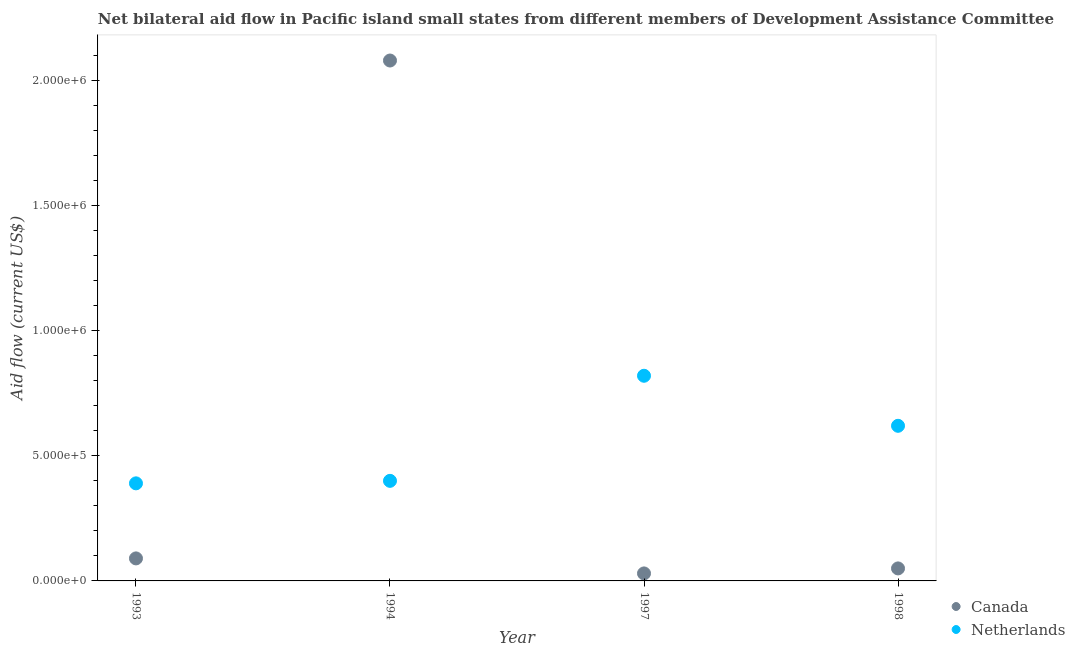How many different coloured dotlines are there?
Offer a very short reply. 2. What is the amount of aid given by canada in 1997?
Make the answer very short. 3.00e+04. Across all years, what is the maximum amount of aid given by canada?
Provide a short and direct response. 2.08e+06. Across all years, what is the minimum amount of aid given by netherlands?
Provide a short and direct response. 3.90e+05. In which year was the amount of aid given by netherlands maximum?
Make the answer very short. 1997. In which year was the amount of aid given by canada minimum?
Offer a terse response. 1997. What is the total amount of aid given by canada in the graph?
Your answer should be compact. 2.25e+06. What is the difference between the amount of aid given by canada in 1997 and that in 1998?
Your response must be concise. -2.00e+04. What is the difference between the amount of aid given by canada in 1997 and the amount of aid given by netherlands in 1993?
Ensure brevity in your answer.  -3.60e+05. What is the average amount of aid given by netherlands per year?
Make the answer very short. 5.58e+05. In the year 1998, what is the difference between the amount of aid given by canada and amount of aid given by netherlands?
Make the answer very short. -5.70e+05. What is the ratio of the amount of aid given by canada in 1993 to that in 1994?
Ensure brevity in your answer.  0.04. What is the difference between the highest and the second highest amount of aid given by canada?
Your response must be concise. 1.99e+06. What is the difference between the highest and the lowest amount of aid given by canada?
Ensure brevity in your answer.  2.05e+06. In how many years, is the amount of aid given by canada greater than the average amount of aid given by canada taken over all years?
Offer a very short reply. 1. Does the amount of aid given by canada monotonically increase over the years?
Provide a succinct answer. No. How many dotlines are there?
Your answer should be compact. 2. Does the graph contain grids?
Offer a terse response. No. Where does the legend appear in the graph?
Your answer should be very brief. Bottom right. How many legend labels are there?
Your response must be concise. 2. What is the title of the graph?
Offer a very short reply. Net bilateral aid flow in Pacific island small states from different members of Development Assistance Committee. Does "Infant" appear as one of the legend labels in the graph?
Offer a terse response. No. What is the Aid flow (current US$) of Canada in 1994?
Make the answer very short. 2.08e+06. What is the Aid flow (current US$) in Canada in 1997?
Your answer should be very brief. 3.00e+04. What is the Aid flow (current US$) of Netherlands in 1997?
Your answer should be compact. 8.20e+05. What is the Aid flow (current US$) of Netherlands in 1998?
Make the answer very short. 6.20e+05. Across all years, what is the maximum Aid flow (current US$) in Canada?
Make the answer very short. 2.08e+06. Across all years, what is the maximum Aid flow (current US$) in Netherlands?
Provide a short and direct response. 8.20e+05. What is the total Aid flow (current US$) of Canada in the graph?
Provide a short and direct response. 2.25e+06. What is the total Aid flow (current US$) of Netherlands in the graph?
Provide a succinct answer. 2.23e+06. What is the difference between the Aid flow (current US$) of Canada in 1993 and that in 1994?
Provide a succinct answer. -1.99e+06. What is the difference between the Aid flow (current US$) of Netherlands in 1993 and that in 1997?
Give a very brief answer. -4.30e+05. What is the difference between the Aid flow (current US$) in Canada in 1993 and that in 1998?
Ensure brevity in your answer.  4.00e+04. What is the difference between the Aid flow (current US$) of Netherlands in 1993 and that in 1998?
Ensure brevity in your answer.  -2.30e+05. What is the difference between the Aid flow (current US$) in Canada in 1994 and that in 1997?
Keep it short and to the point. 2.05e+06. What is the difference between the Aid flow (current US$) of Netherlands in 1994 and that in 1997?
Provide a short and direct response. -4.20e+05. What is the difference between the Aid flow (current US$) in Canada in 1994 and that in 1998?
Provide a short and direct response. 2.03e+06. What is the difference between the Aid flow (current US$) in Netherlands in 1997 and that in 1998?
Your response must be concise. 2.00e+05. What is the difference between the Aid flow (current US$) in Canada in 1993 and the Aid flow (current US$) in Netherlands in 1994?
Your answer should be very brief. -3.10e+05. What is the difference between the Aid flow (current US$) of Canada in 1993 and the Aid flow (current US$) of Netherlands in 1997?
Ensure brevity in your answer.  -7.30e+05. What is the difference between the Aid flow (current US$) in Canada in 1993 and the Aid flow (current US$) in Netherlands in 1998?
Provide a short and direct response. -5.30e+05. What is the difference between the Aid flow (current US$) in Canada in 1994 and the Aid flow (current US$) in Netherlands in 1997?
Ensure brevity in your answer.  1.26e+06. What is the difference between the Aid flow (current US$) of Canada in 1994 and the Aid flow (current US$) of Netherlands in 1998?
Offer a terse response. 1.46e+06. What is the difference between the Aid flow (current US$) of Canada in 1997 and the Aid flow (current US$) of Netherlands in 1998?
Provide a short and direct response. -5.90e+05. What is the average Aid flow (current US$) of Canada per year?
Give a very brief answer. 5.62e+05. What is the average Aid flow (current US$) in Netherlands per year?
Offer a very short reply. 5.58e+05. In the year 1994, what is the difference between the Aid flow (current US$) in Canada and Aid flow (current US$) in Netherlands?
Your response must be concise. 1.68e+06. In the year 1997, what is the difference between the Aid flow (current US$) in Canada and Aid flow (current US$) in Netherlands?
Offer a terse response. -7.90e+05. In the year 1998, what is the difference between the Aid flow (current US$) of Canada and Aid flow (current US$) of Netherlands?
Provide a short and direct response. -5.70e+05. What is the ratio of the Aid flow (current US$) of Canada in 1993 to that in 1994?
Offer a very short reply. 0.04. What is the ratio of the Aid flow (current US$) in Netherlands in 1993 to that in 1997?
Give a very brief answer. 0.48. What is the ratio of the Aid flow (current US$) in Netherlands in 1993 to that in 1998?
Make the answer very short. 0.63. What is the ratio of the Aid flow (current US$) of Canada in 1994 to that in 1997?
Offer a terse response. 69.33. What is the ratio of the Aid flow (current US$) in Netherlands in 1994 to that in 1997?
Give a very brief answer. 0.49. What is the ratio of the Aid flow (current US$) of Canada in 1994 to that in 1998?
Ensure brevity in your answer.  41.6. What is the ratio of the Aid flow (current US$) in Netherlands in 1994 to that in 1998?
Your answer should be very brief. 0.65. What is the ratio of the Aid flow (current US$) in Netherlands in 1997 to that in 1998?
Offer a terse response. 1.32. What is the difference between the highest and the second highest Aid flow (current US$) of Canada?
Provide a succinct answer. 1.99e+06. What is the difference between the highest and the second highest Aid flow (current US$) of Netherlands?
Keep it short and to the point. 2.00e+05. What is the difference between the highest and the lowest Aid flow (current US$) in Canada?
Ensure brevity in your answer.  2.05e+06. What is the difference between the highest and the lowest Aid flow (current US$) in Netherlands?
Make the answer very short. 4.30e+05. 